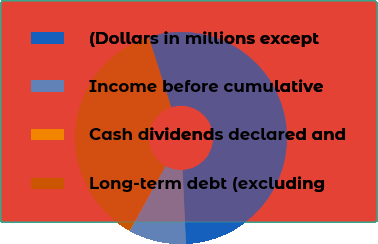Convert chart to OTSL. <chart><loc_0><loc_0><loc_500><loc_500><pie_chart><fcel>(Dollars in millions except<fcel>Income before cumulative<fcel>Cash dividends declared and<fcel>Long-term debt (excluding<nl><fcel>54.2%<fcel>8.78%<fcel>0.05%<fcel>36.98%<nl></chart> 